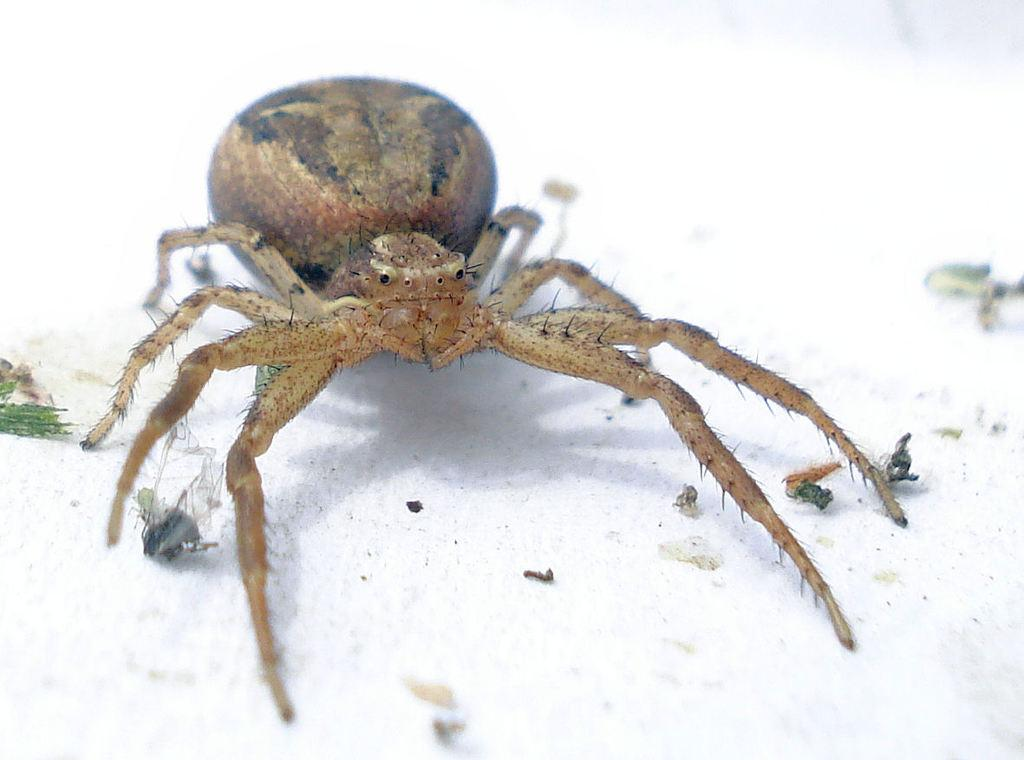What type of insect is on the floor in the image? There is a spider on the floor in the image. Are there any other insects present on the floor? Yes, there are small mosquitoes on the floor. What type of nerve can be seen in the image? There is no nerve present in the image; it features a spider and mosquitoes on the floor. How many planes are visible in the image? There are no planes visible in the image. 